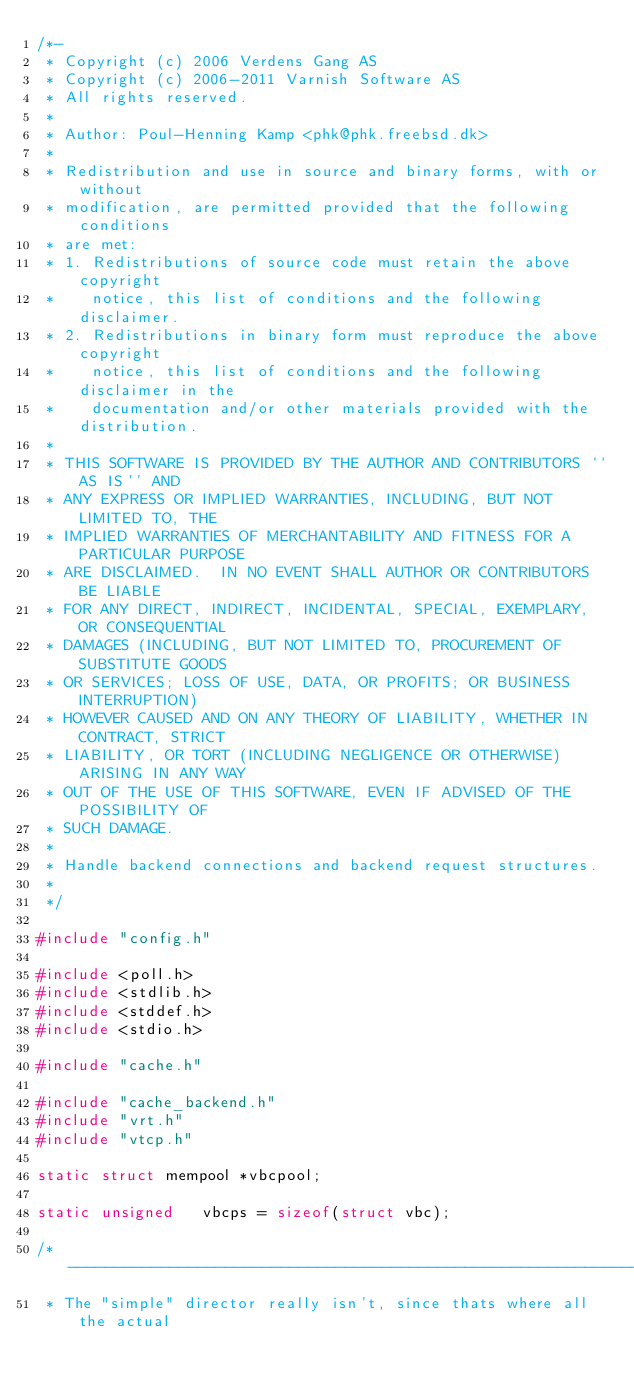<code> <loc_0><loc_0><loc_500><loc_500><_C_>/*-
 * Copyright (c) 2006 Verdens Gang AS
 * Copyright (c) 2006-2011 Varnish Software AS
 * All rights reserved.
 *
 * Author: Poul-Henning Kamp <phk@phk.freebsd.dk>
 *
 * Redistribution and use in source and binary forms, with or without
 * modification, are permitted provided that the following conditions
 * are met:
 * 1. Redistributions of source code must retain the above copyright
 *    notice, this list of conditions and the following disclaimer.
 * 2. Redistributions in binary form must reproduce the above copyright
 *    notice, this list of conditions and the following disclaimer in the
 *    documentation and/or other materials provided with the distribution.
 *
 * THIS SOFTWARE IS PROVIDED BY THE AUTHOR AND CONTRIBUTORS ``AS IS'' AND
 * ANY EXPRESS OR IMPLIED WARRANTIES, INCLUDING, BUT NOT LIMITED TO, THE
 * IMPLIED WARRANTIES OF MERCHANTABILITY AND FITNESS FOR A PARTICULAR PURPOSE
 * ARE DISCLAIMED.  IN NO EVENT SHALL AUTHOR OR CONTRIBUTORS BE LIABLE
 * FOR ANY DIRECT, INDIRECT, INCIDENTAL, SPECIAL, EXEMPLARY, OR CONSEQUENTIAL
 * DAMAGES (INCLUDING, BUT NOT LIMITED TO, PROCUREMENT OF SUBSTITUTE GOODS
 * OR SERVICES; LOSS OF USE, DATA, OR PROFITS; OR BUSINESS INTERRUPTION)
 * HOWEVER CAUSED AND ON ANY THEORY OF LIABILITY, WHETHER IN CONTRACT, STRICT
 * LIABILITY, OR TORT (INCLUDING NEGLIGENCE OR OTHERWISE) ARISING IN ANY WAY
 * OUT OF THE USE OF THIS SOFTWARE, EVEN IF ADVISED OF THE POSSIBILITY OF
 * SUCH DAMAGE.
 *
 * Handle backend connections and backend request structures.
 *
 */

#include "config.h"

#include <poll.h>
#include <stdlib.h>
#include <stddef.h>
#include <stdio.h>

#include "cache.h"

#include "cache_backend.h"
#include "vrt.h"
#include "vtcp.h"

static struct mempool	*vbcpool;

static unsigned		vbcps = sizeof(struct vbc);

/*--------------------------------------------------------------------
 * The "simple" director really isn't, since thats where all the actual</code> 